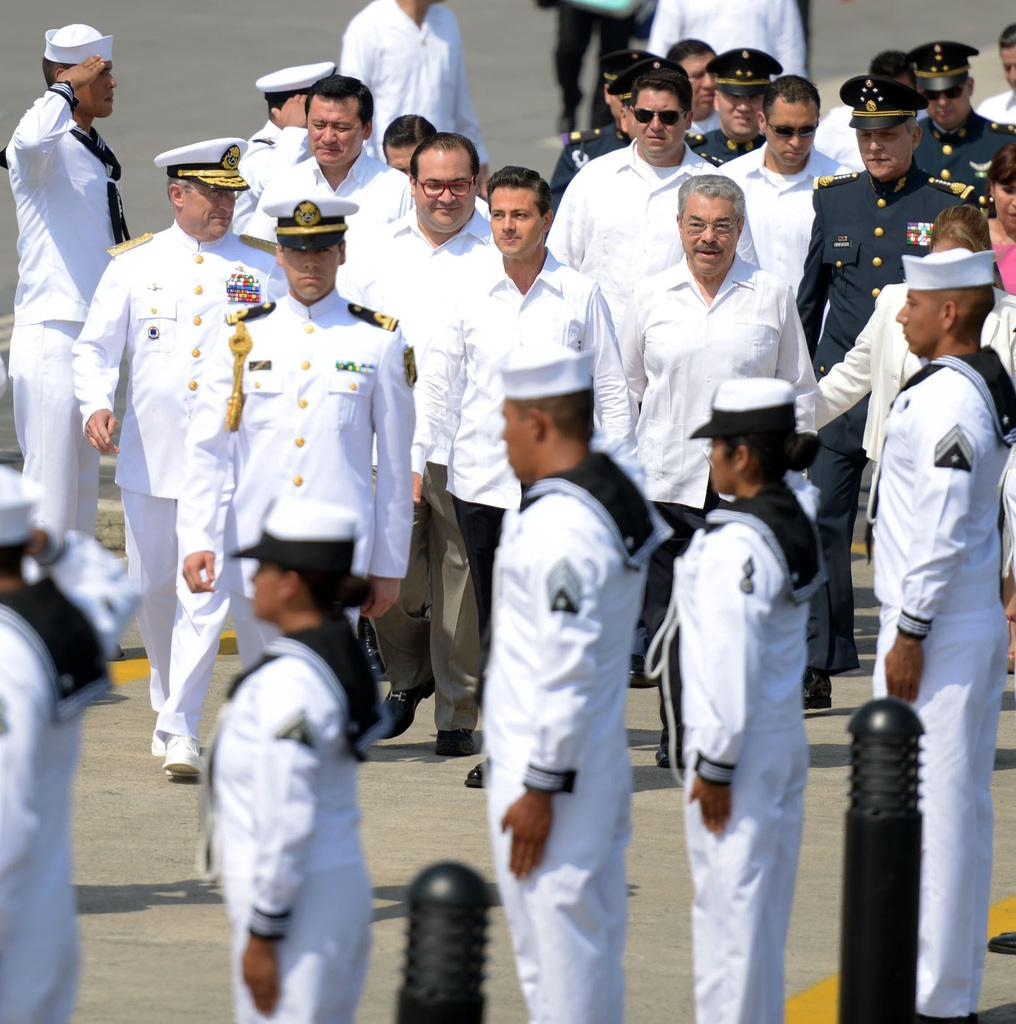What is the main subject of the image? The main subject of the image is a group of people. What are some of the people in the image doing? Some people are standing, while others are walking. What color clothes are some of the people wearing? Some people are wearing white clothes. What objects can be seen in the image besides the people? Metal rods are present in the image. What type of shoe can be seen on the person walking in the image? There is no shoe visible in the image, as the people are not wearing any footwear. How long does it take for the idea to be implemented in the image? There is no mention of an idea or its implementation in the image. 